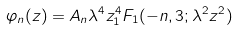<formula> <loc_0><loc_0><loc_500><loc_500>\varphi _ { n } ( z ) = A _ { n } \lambda ^ { 4 } z ^ { 4 } _ { 1 } F _ { 1 } ( - n , 3 ; \lambda ^ { 2 } z ^ { 2 } )</formula> 